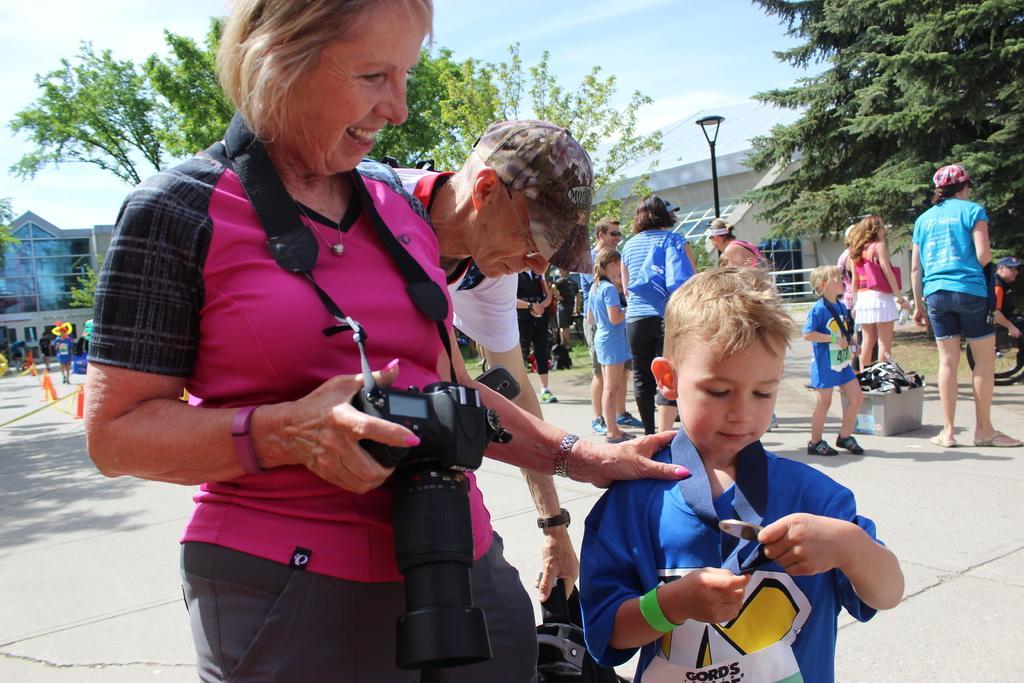How would you summarize this image in a sentence or two? In the picture we can find some people are standing, and a woman holding a camera with the child, in the background we can find some trees, sky, and lights. 